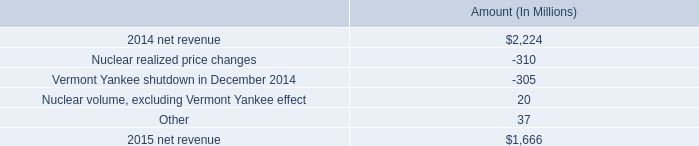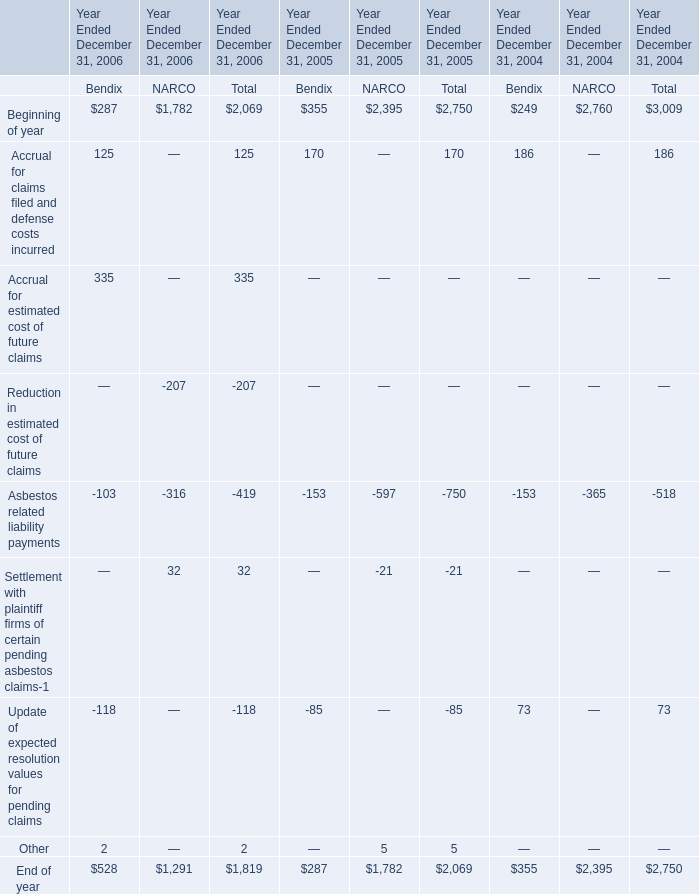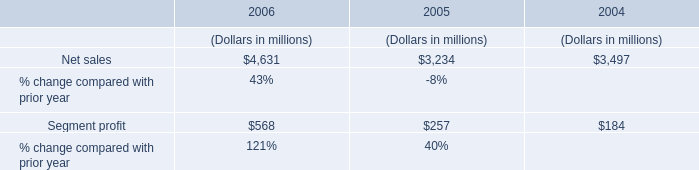Which year is Accrual for claims filed and defense costs incurred greater than 100 ? 
Answer: 2004 2005 2006. What is the sum of the Asbestos related liability payments in the years where Accrual for claims filed and defense costs incurred is greater than 100 for Bendix? 
Computations: ((-103 - 153) - 153)
Answer: -409.0. Does the value of Accrual for claims filed and defense costs incurred in 2006 greater than that in 2005? 
Answer: no. 